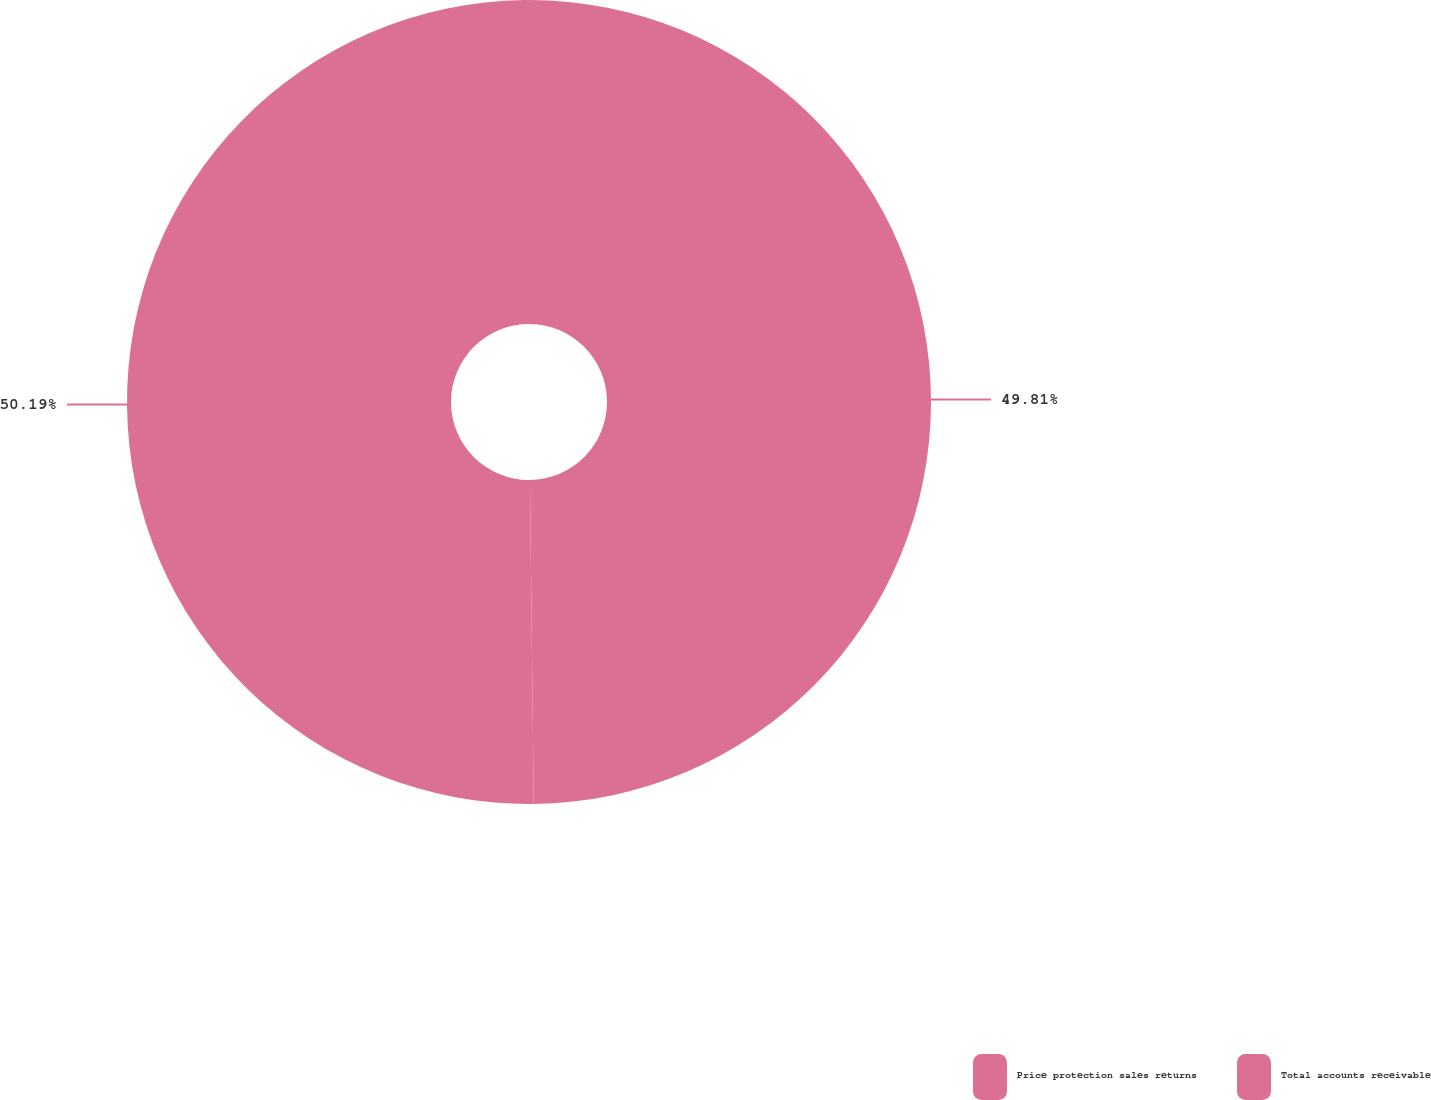Convert chart to OTSL. <chart><loc_0><loc_0><loc_500><loc_500><pie_chart><fcel>Price protection sales returns<fcel>Total accounts receivable<nl><fcel>49.81%<fcel>50.19%<nl></chart> 